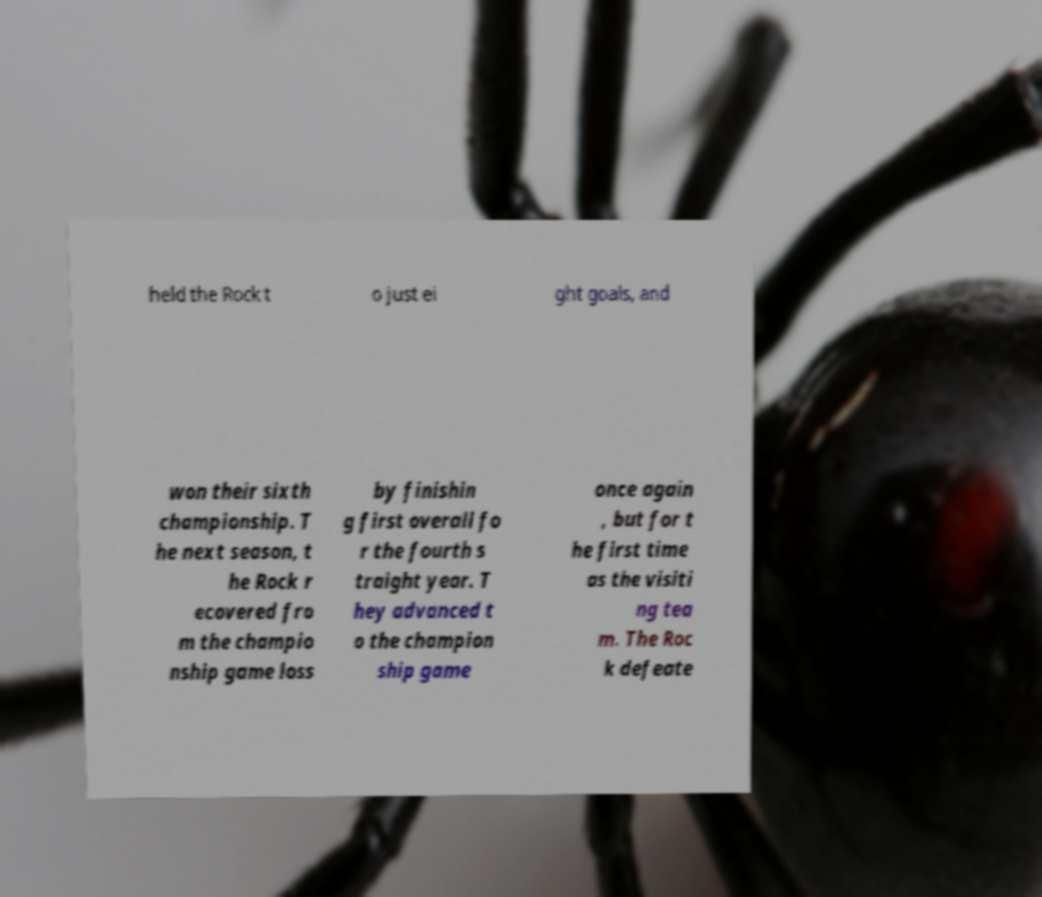Can you accurately transcribe the text from the provided image for me? held the Rock t o just ei ght goals, and won their sixth championship. T he next season, t he Rock r ecovered fro m the champio nship game loss by finishin g first overall fo r the fourth s traight year. T hey advanced t o the champion ship game once again , but for t he first time as the visiti ng tea m. The Roc k defeate 